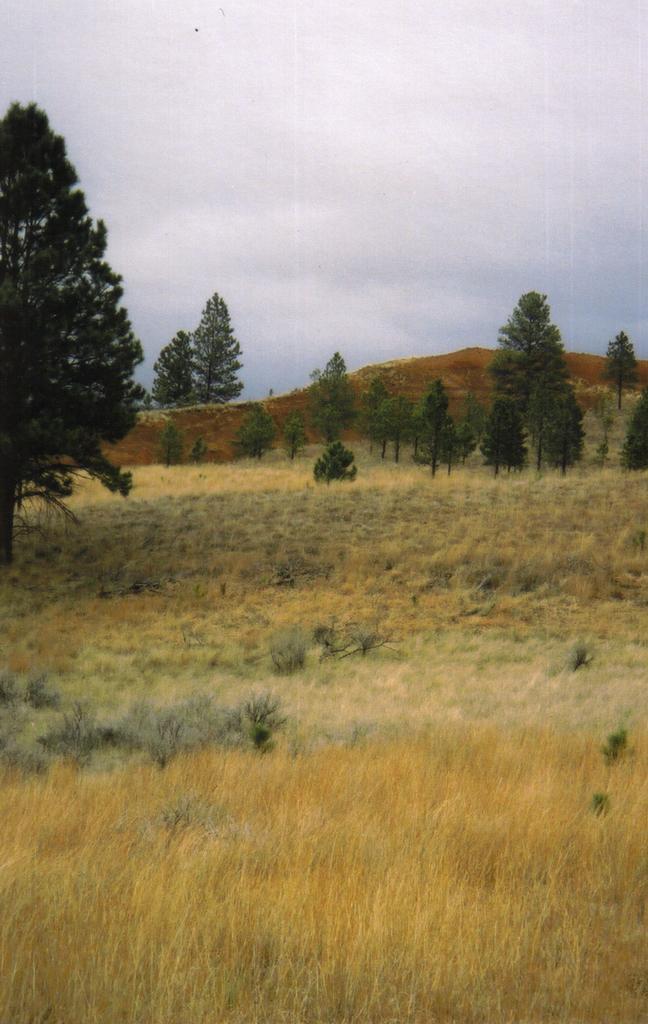Please provide a concise description of this image. We can see grass. In the background we can see trees,hill and sky. 